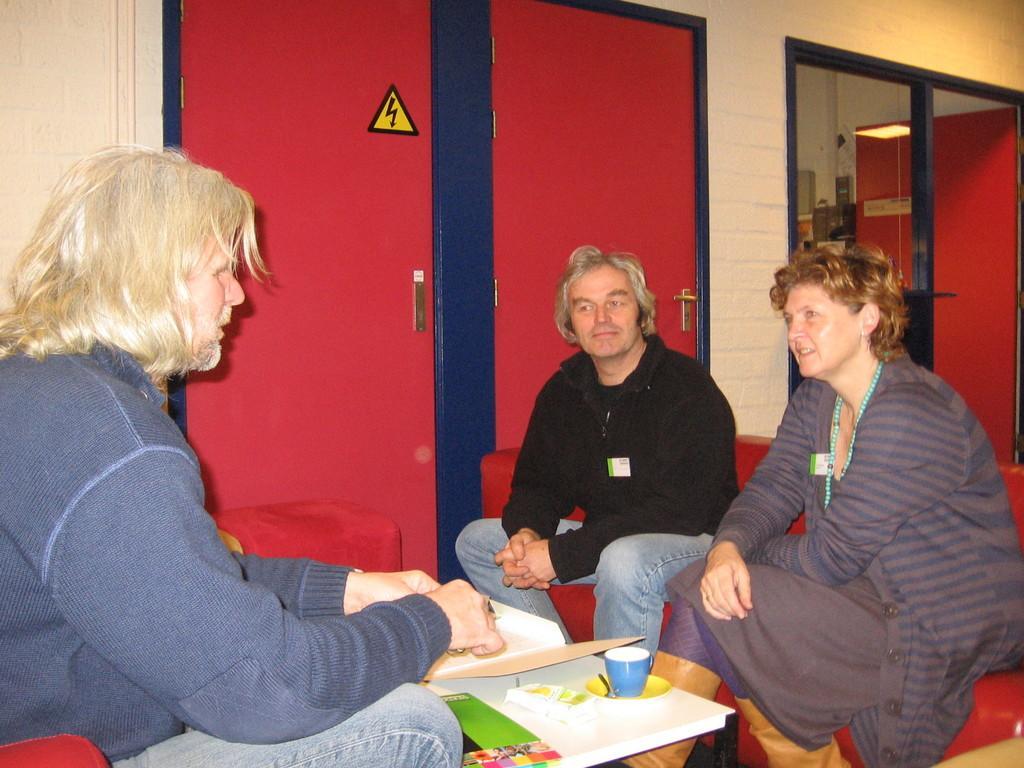Please provide a concise description of this image. In this image there are three persons sitting on a sofa, towards the left there is a person wearing blue sweater and blue jeans, towards the right there is a man and a woman. Woman is wearing a striped sweater and man is wearing a black t shirt. In the middle there is a bench. on the bench, there is a cup and books. In the background there are red color cupboards and a window. 